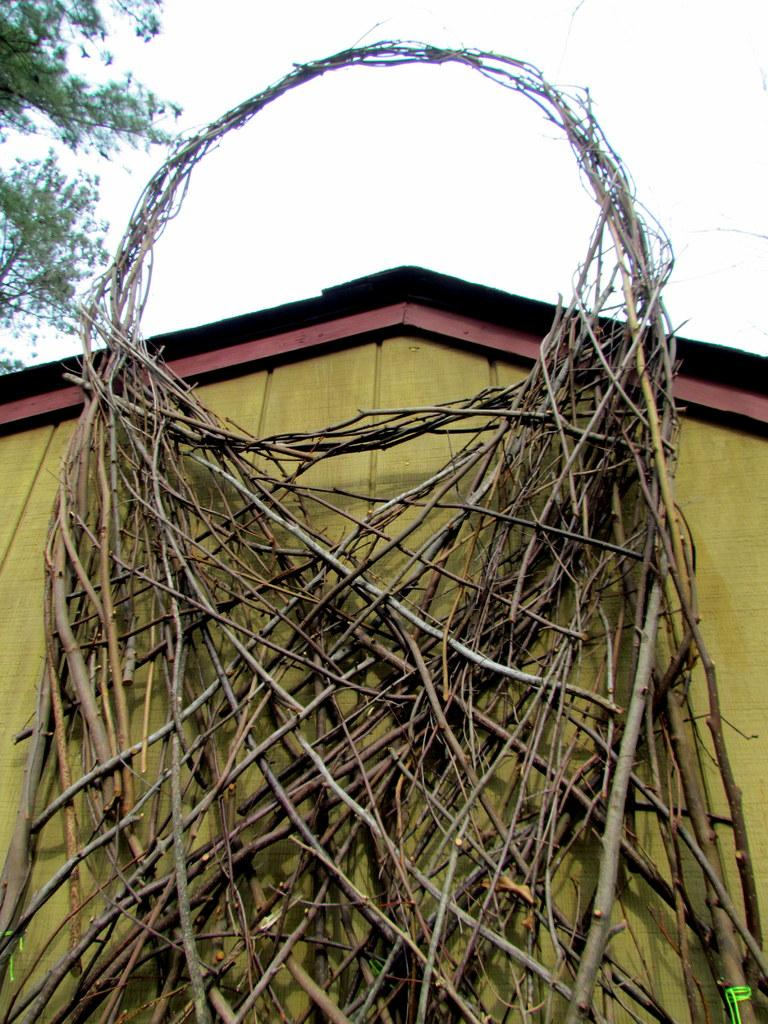What type of material is used for the wall in the image? There is a wooden wall in the image. What can be seen in the background of the image? There are trees in the image. What is the wealth of the trees in the image? There is no indication of the trees' wealth in the image, as trees do not possess wealth. 